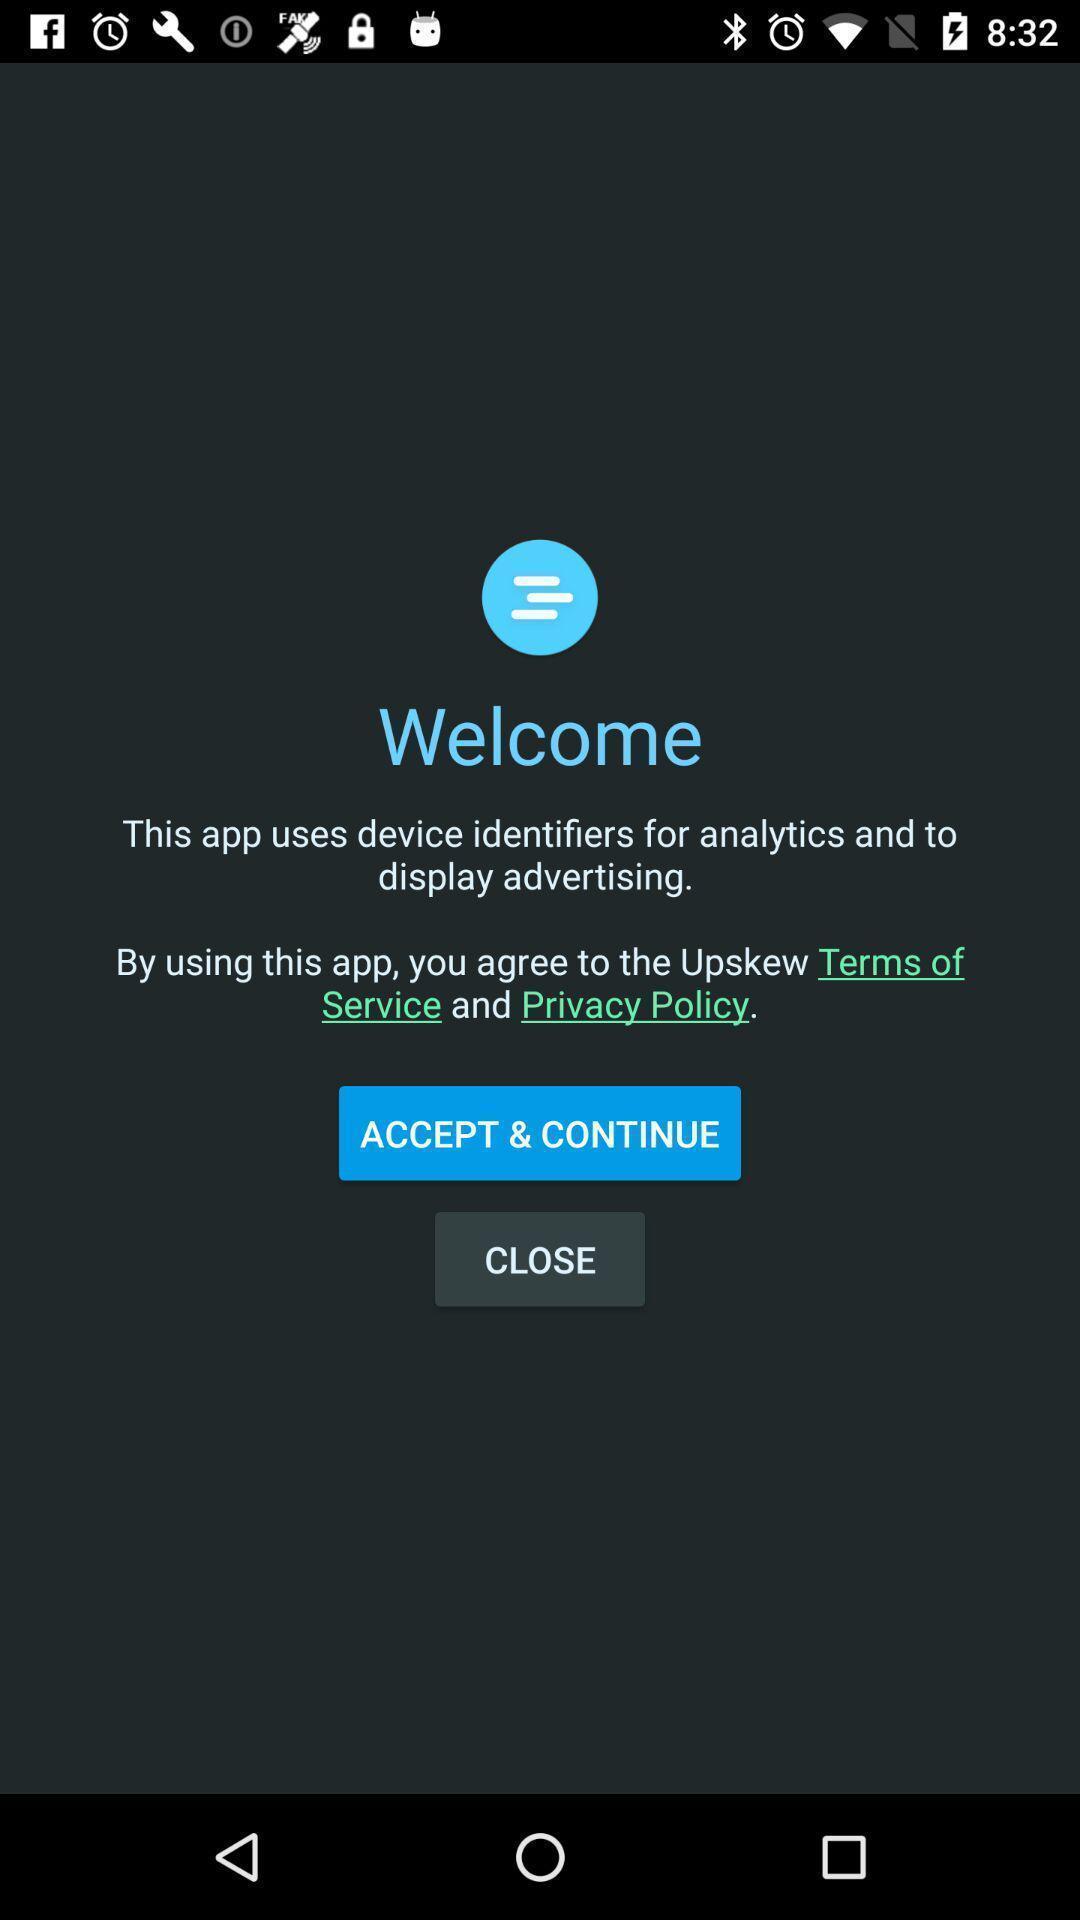Explain what's happening in this screen capture. Welcome page of social app. 